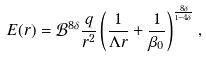Convert formula to latex. <formula><loc_0><loc_0><loc_500><loc_500>E ( r ) = \mathcal { B } ^ { 8 \delta } \frac { q } { r ^ { 2 } } \left ( \frac { 1 } { \Lambda r } + \frac { 1 } { \beta _ { 0 } } \right ) ^ { \frac { 8 \delta } { 1 - 4 \delta } } ,</formula> 